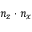<formula> <loc_0><loc_0><loc_500><loc_500>n _ { z } \cdot n _ { x }</formula> 